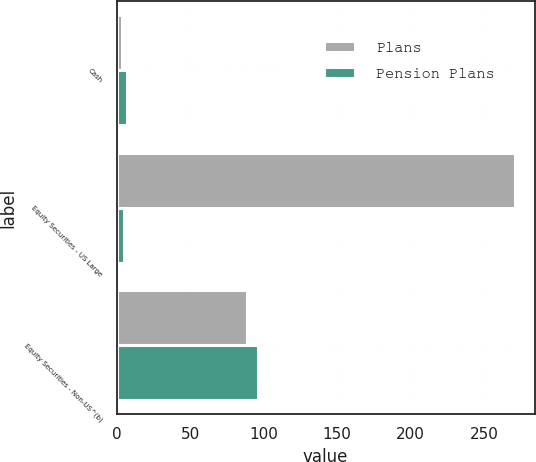<chart> <loc_0><loc_0><loc_500><loc_500><stacked_bar_chart><ecel><fcel>Cash<fcel>Equity Securities - US Large<fcel>Equity Securities - Non-US^(b)<nl><fcel>Plans<fcel>4<fcel>271<fcel>89<nl><fcel>Pension Plans<fcel>7<fcel>5<fcel>96<nl></chart> 